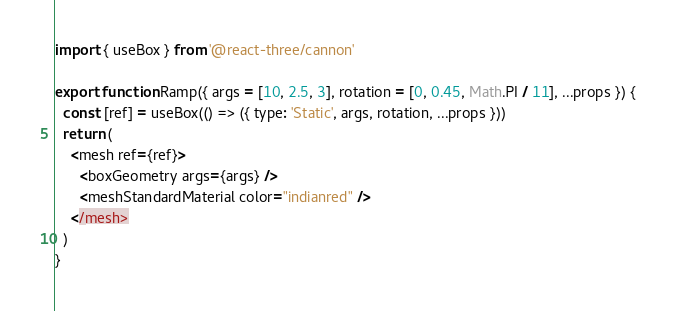Convert code to text. <code><loc_0><loc_0><loc_500><loc_500><_JavaScript_>import { useBox } from '@react-three/cannon'

export function Ramp({ args = [10, 2.5, 3], rotation = [0, 0.45, Math.PI / 11], ...props }) {
  const [ref] = useBox(() => ({ type: 'Static', args, rotation, ...props }))
  return (
    <mesh ref={ref}>
      <boxGeometry args={args} />
      <meshStandardMaterial color="indianred" />
    </mesh>
  )
}
</code> 